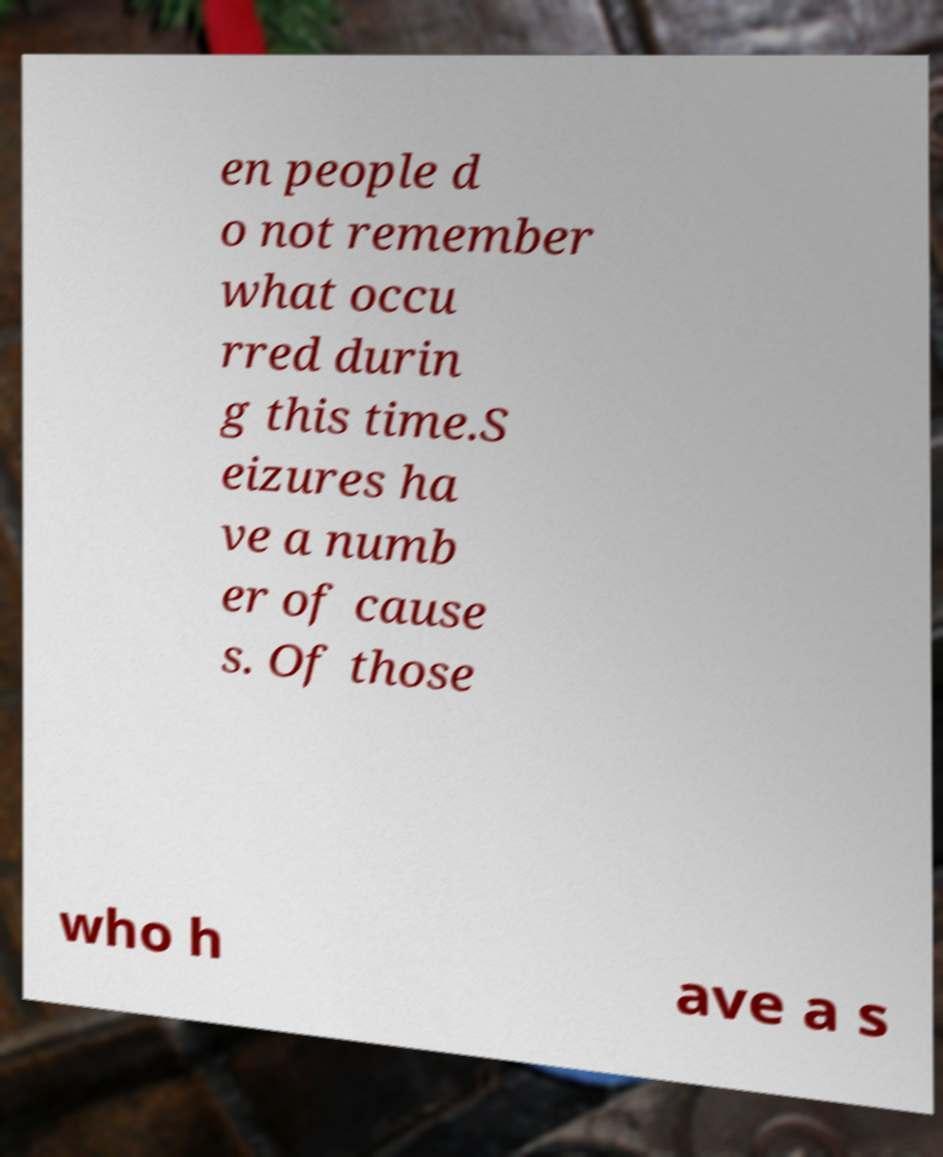For documentation purposes, I need the text within this image transcribed. Could you provide that? en people d o not remember what occu rred durin g this time.S eizures ha ve a numb er of cause s. Of those who h ave a s 